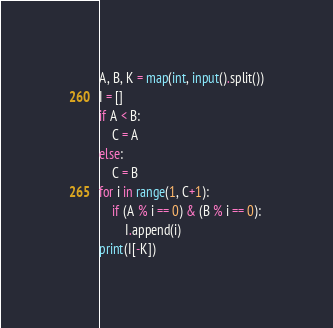<code> <loc_0><loc_0><loc_500><loc_500><_Python_>A, B, K = map(int, input().split())
I = []
if A < B:
    C = A
else:
    C = B
for i in range(1, C+1):
    if (A % i == 0) & (B % i == 0):
        I.append(i)
print(I[-K])
</code> 